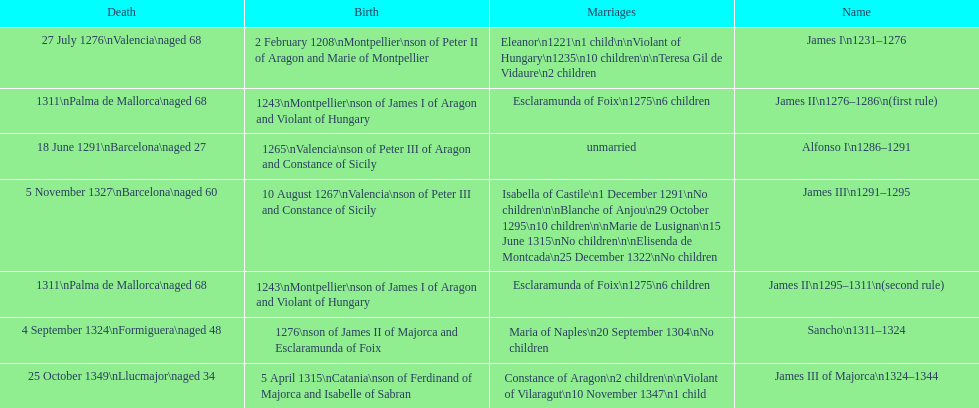Who was the monarch with the greatest number of marital unions? James III 1291-1295. 